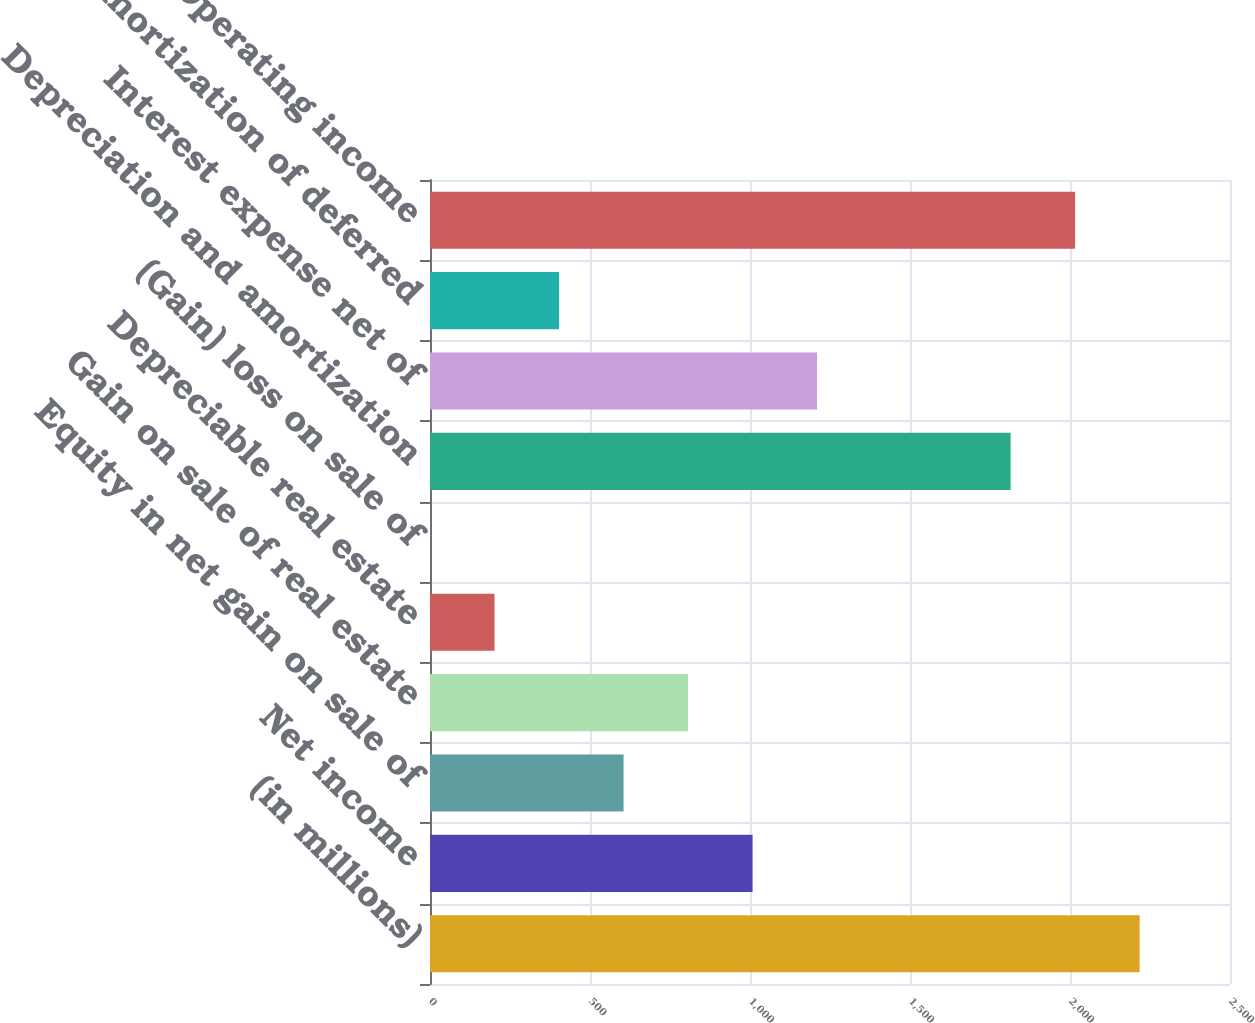<chart> <loc_0><loc_0><loc_500><loc_500><bar_chart><fcel>(in millions)<fcel>Net income<fcel>Equity in net gain on sale of<fcel>Gain on sale of real estate<fcel>Depreciable real estate<fcel>(Gain) loss on sale of<fcel>Depreciation and amortization<fcel>Interest expense net of<fcel>Amortization of deferred<fcel>Operating income<nl><fcel>2217.59<fcel>1008.05<fcel>604.87<fcel>806.46<fcel>201.69<fcel>0.1<fcel>1814.41<fcel>1209.64<fcel>403.28<fcel>2016<nl></chart> 